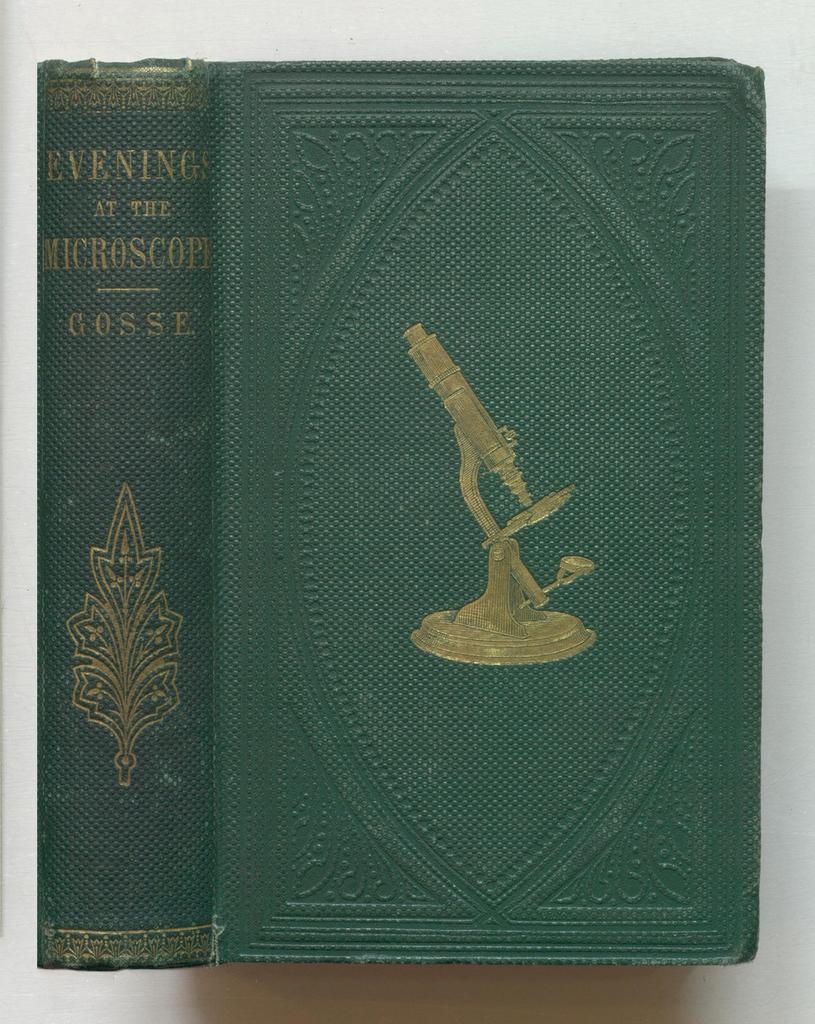Who is this book by?
Your answer should be compact. Gosse. 